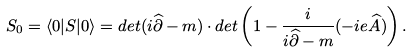Convert formula to latex. <formula><loc_0><loc_0><loc_500><loc_500>S _ { 0 } = \langle 0 | S | 0 \rangle = d e t ( i \widehat { \partial } - m ) \cdot d e t \left ( 1 - \frac { i } { i \widehat { \partial } - m } ( - i e \widehat { A } ) \right ) .</formula> 